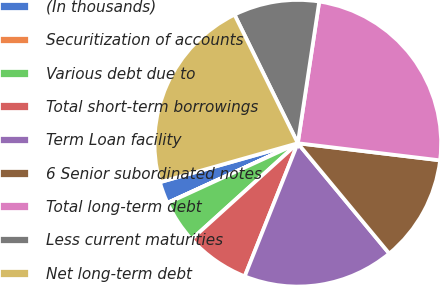Convert chart to OTSL. <chart><loc_0><loc_0><loc_500><loc_500><pie_chart><fcel>(In thousands)<fcel>Securitization of accounts<fcel>Various debt due to<fcel>Total short-term borrowings<fcel>Term Loan facility<fcel>6 Senior subordinated notes<fcel>Total long-term debt<fcel>Less current maturities<fcel>Net long-term debt<nl><fcel>2.44%<fcel>0.03%<fcel>4.85%<fcel>7.26%<fcel>17.06%<fcel>12.08%<fcel>24.52%<fcel>9.67%<fcel>22.11%<nl></chart> 